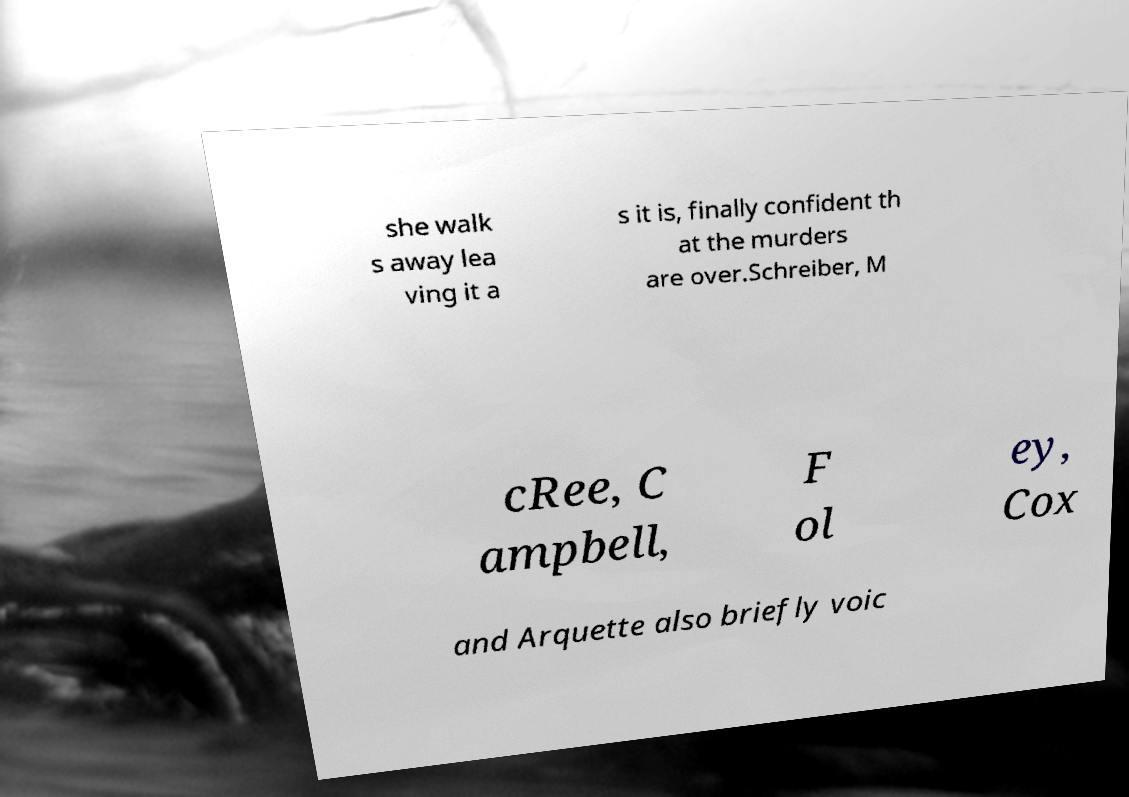Can you accurately transcribe the text from the provided image for me? she walk s away lea ving it a s it is, finally confident th at the murders are over.Schreiber, M cRee, C ampbell, F ol ey, Cox and Arquette also briefly voic 